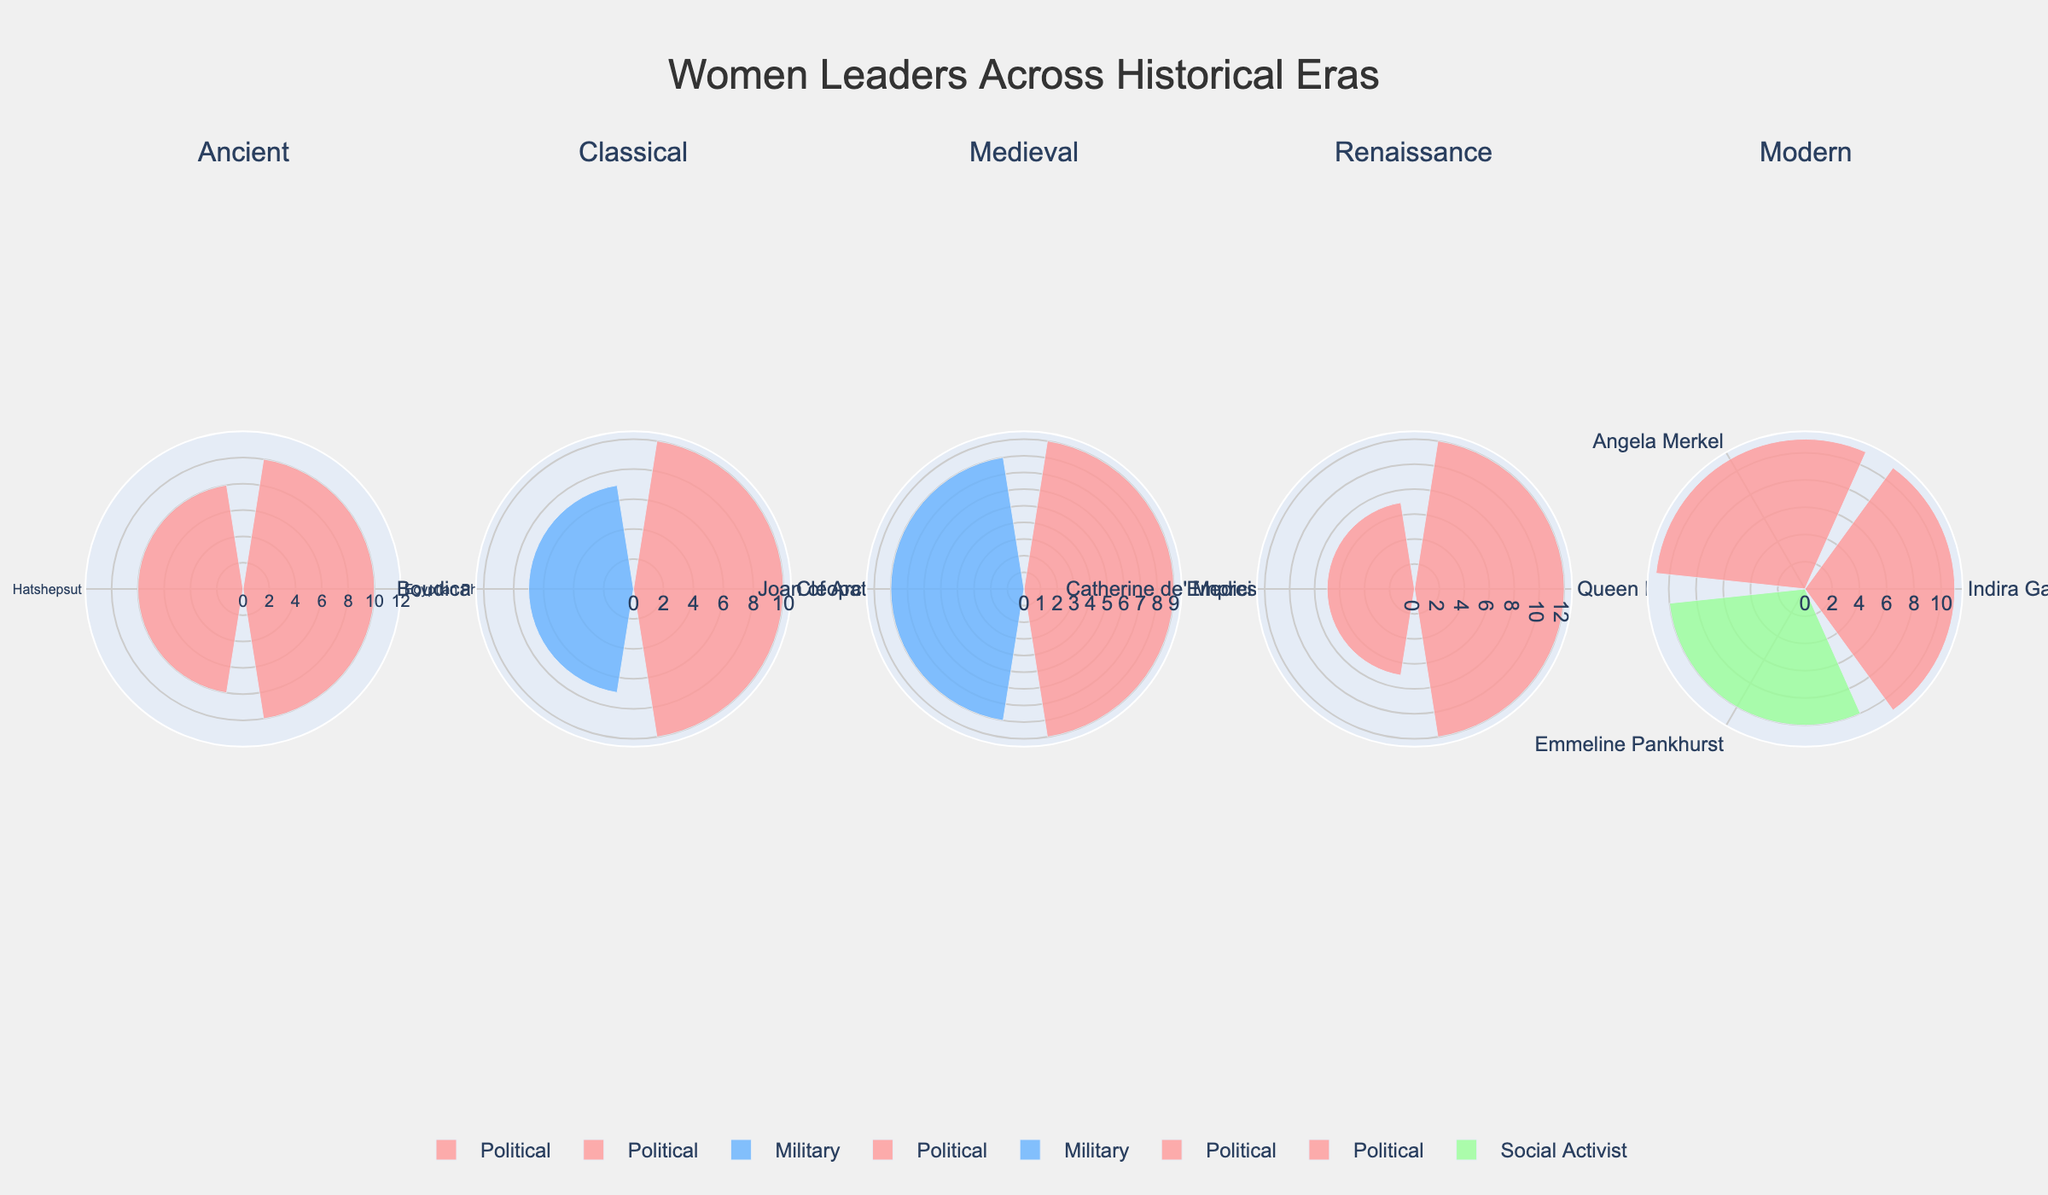What is the title of the figure? The title of the figure is located at the top and provides a brief summary of what the figure represents. Here, the title directly informs the viewer about the content of the figure, which is related to the distribution of women leaders across different historical eras.
Answer: Women Leaders Across Historical Eras How many women leaders are included from the Renaissance era? The Renaissance era subplot includes leaders marked with their names around the plot. By counting these names, we can determine the number of leaders from this era.
Answer: 2 Which era has the highest frequency of women leaders categorized as political? To determine this, we need to look at each subplot and compare the frequencies denoted by the bar lengths for political leaders. By summing the frequencies of political leaders in each era, the era with the highest sum can be identified.
Answer: Renaissance In which era is the frequency of military leaders equivalent to the frequency of political leaders in the Classical era? For this, we compare the frequencies of military leaders from each era with the sum of frequencies of political leaders in the Classical era, which is 10 (Cleopatra VII) + 7 (Boudica) = 17. By checking the military leaders' frequencies, we find a match.
Answer: Medieval (9 + 8 = 17) Which leader from the Modern era has the highest frequency? We can identify the leader with the highest frequency by comparing the length of the bars for each leader within the Modern era subplot.
Answer: Indira Gandhi Compare the frequency of Egyptian Pharaoh Cleopatra I and Cleopatra VII. Which one has a higher frequency? We look at the subplots for the Ancient and Classical eras, check the frequencies marked for both leaders, and compare them to see which one has a higher number.
Answer: Cleopatra VII What is the total frequency of social activists in the Modern era? In the subplot for the Modern era, the only social activist listed is Emmeline Pankhurst. By checking her frequency and summing it up, we get the total.
Answer: 10 Do any eras have no military leaders represented? We need to check the categories present in each subplot to see if any era lacks a military leader. An era without any bars or leaders listed under the military category would be our answer.
Answer: Ancient and Renaissance Compare the total frequencies of all leaders in the Medieval era to those in the Ancient era. Which era has a higher total frequency? Sum the frequencies of all leaders in the Medieval era and the Ancient era separately and compare the sums. Medieval total: Empress Matilda (9) + Joan of Arc (8) = 17. Ancient total: Cleopatra I (10) + Hatshepsut (8) = 18.
Answer: Ancient Which leader in the figure has the least frequency, and what is that frequency? By comparing all the individual frequencies marked next to each leader's name in all subplots, we can identify the leader with the smallest number.
Answer: Catherine de' Medici (7) 